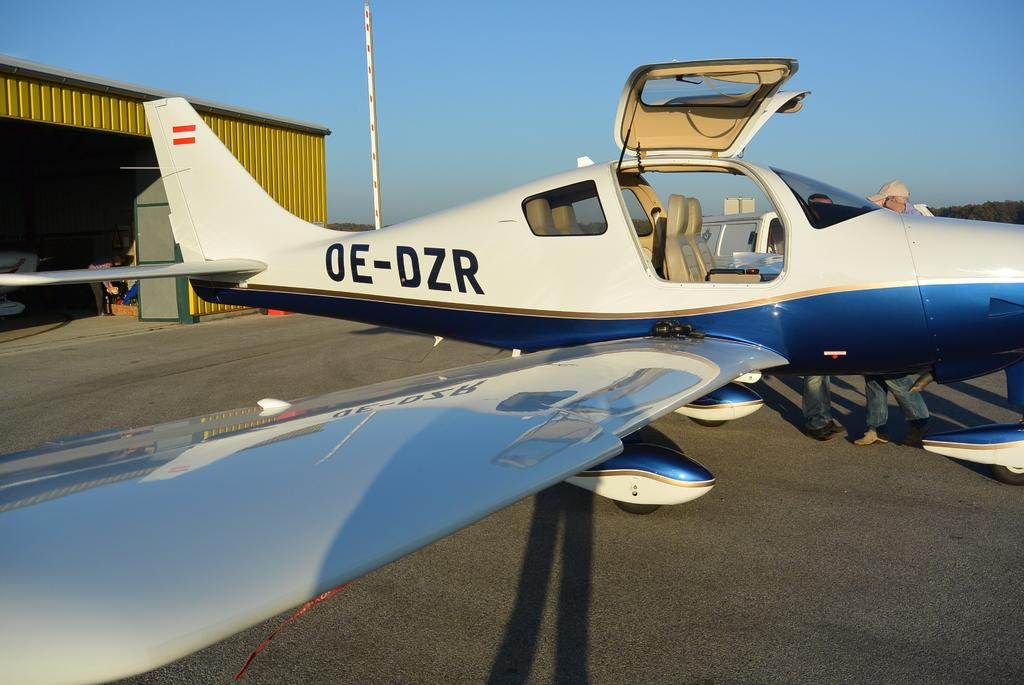Provide a one-sentence caption for the provided image. A small plane OE-DZR is outside the hangar with its doors opened. 